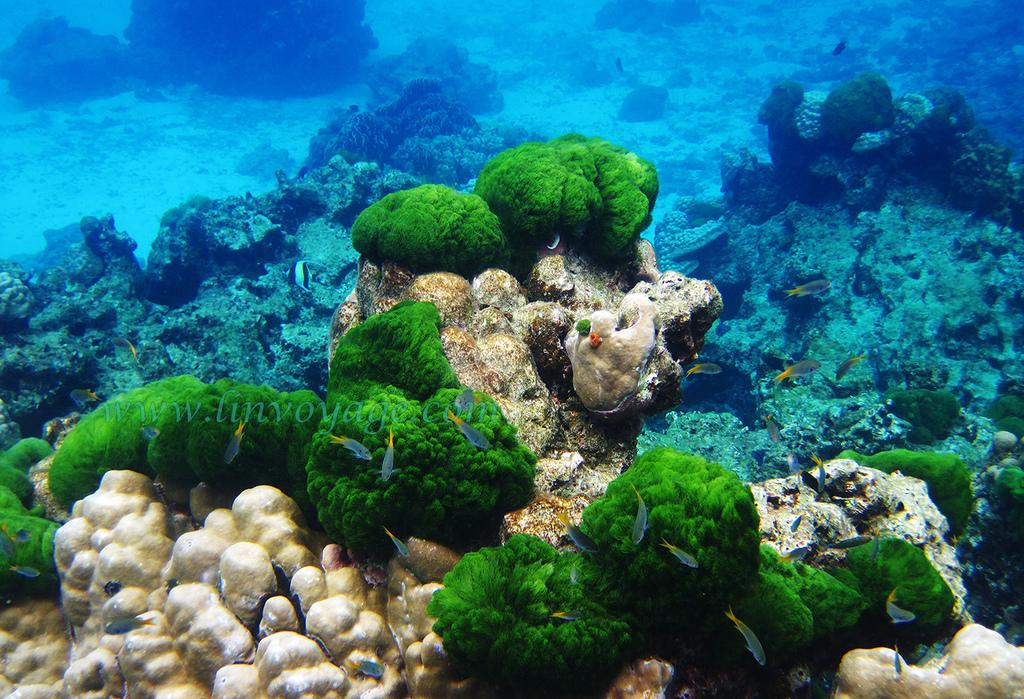What is the main subject of the image? The main subject of the image is the inside of water. What types of vegetation can be seen in the image? There are sea plants visible in the image. What other living organisms are present in the image? There are fishes in the image. Can you describe any additional features of the image? There is a watermark in the middle of the picture. What type of doctor can be seen treating a patient in the image? There is no doctor or patient present in the image; it shows the inside of water with sea plants and fishes. How is the wealth of the fish depicted in the image? There is no depiction of wealth in the image; it simply shows the natural environment of the fish. 